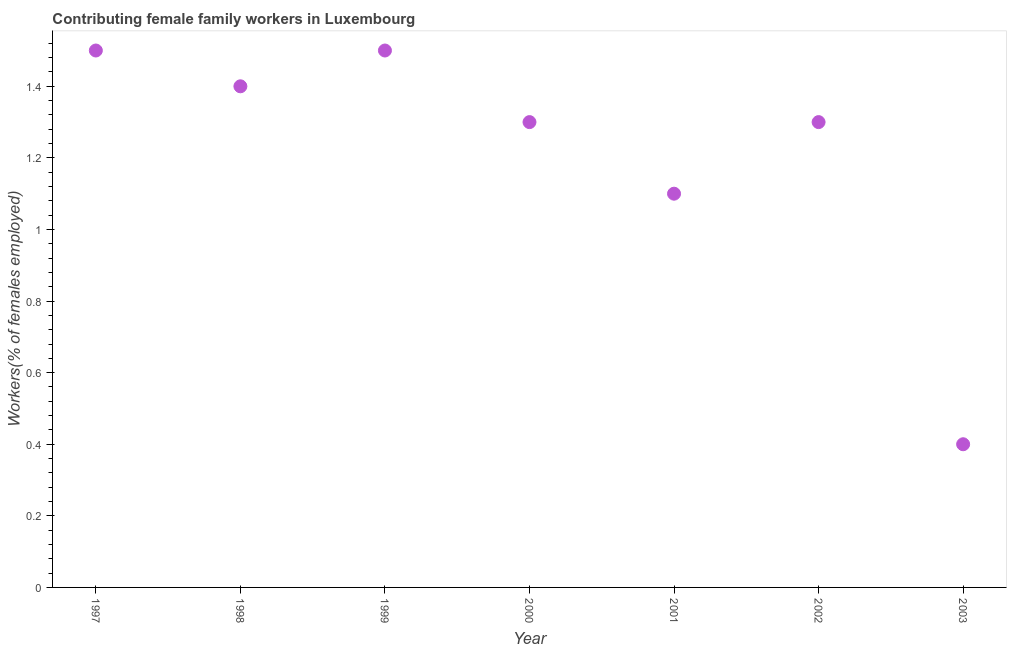What is the contributing female family workers in 2000?
Provide a succinct answer. 1.3. Across all years, what is the minimum contributing female family workers?
Offer a very short reply. 0.4. In which year was the contributing female family workers minimum?
Your response must be concise. 2003. What is the sum of the contributing female family workers?
Provide a succinct answer. 8.5. What is the difference between the contributing female family workers in 1998 and 2000?
Make the answer very short. 0.1. What is the average contributing female family workers per year?
Your response must be concise. 1.21. What is the median contributing female family workers?
Provide a short and direct response. 1.3. In how many years, is the contributing female family workers greater than 1.36 %?
Keep it short and to the point. 3. What is the ratio of the contributing female family workers in 2001 to that in 2002?
Give a very brief answer. 0.85. Is the sum of the contributing female family workers in 1999 and 2003 greater than the maximum contributing female family workers across all years?
Your answer should be compact. Yes. What is the difference between the highest and the lowest contributing female family workers?
Ensure brevity in your answer.  1.1. How many years are there in the graph?
Make the answer very short. 7. Does the graph contain grids?
Ensure brevity in your answer.  No. What is the title of the graph?
Provide a succinct answer. Contributing female family workers in Luxembourg. What is the label or title of the X-axis?
Provide a succinct answer. Year. What is the label or title of the Y-axis?
Give a very brief answer. Workers(% of females employed). What is the Workers(% of females employed) in 1997?
Provide a succinct answer. 1.5. What is the Workers(% of females employed) in 1998?
Your response must be concise. 1.4. What is the Workers(% of females employed) in 1999?
Your answer should be compact. 1.5. What is the Workers(% of females employed) in 2000?
Give a very brief answer. 1.3. What is the Workers(% of females employed) in 2001?
Make the answer very short. 1.1. What is the Workers(% of females employed) in 2002?
Ensure brevity in your answer.  1.3. What is the Workers(% of females employed) in 2003?
Provide a short and direct response. 0.4. What is the difference between the Workers(% of females employed) in 1997 and 1998?
Give a very brief answer. 0.1. What is the difference between the Workers(% of females employed) in 1997 and 2001?
Your response must be concise. 0.4. What is the difference between the Workers(% of females employed) in 1997 and 2002?
Provide a short and direct response. 0.2. What is the difference between the Workers(% of females employed) in 1997 and 2003?
Your response must be concise. 1.1. What is the difference between the Workers(% of females employed) in 1998 and 2000?
Your answer should be compact. 0.1. What is the difference between the Workers(% of females employed) in 1998 and 2001?
Ensure brevity in your answer.  0.3. What is the difference between the Workers(% of females employed) in 1998 and 2002?
Offer a very short reply. 0.1. What is the difference between the Workers(% of females employed) in 1999 and 2000?
Your answer should be very brief. 0.2. What is the difference between the Workers(% of females employed) in 2000 and 2001?
Your answer should be compact. 0.2. What is the difference between the Workers(% of females employed) in 2000 and 2002?
Offer a very short reply. 0. What is the difference between the Workers(% of females employed) in 2000 and 2003?
Keep it short and to the point. 0.9. What is the difference between the Workers(% of females employed) in 2001 and 2003?
Provide a succinct answer. 0.7. What is the ratio of the Workers(% of females employed) in 1997 to that in 1998?
Make the answer very short. 1.07. What is the ratio of the Workers(% of females employed) in 1997 to that in 1999?
Ensure brevity in your answer.  1. What is the ratio of the Workers(% of females employed) in 1997 to that in 2000?
Your answer should be compact. 1.15. What is the ratio of the Workers(% of females employed) in 1997 to that in 2001?
Ensure brevity in your answer.  1.36. What is the ratio of the Workers(% of females employed) in 1997 to that in 2002?
Make the answer very short. 1.15. What is the ratio of the Workers(% of females employed) in 1997 to that in 2003?
Make the answer very short. 3.75. What is the ratio of the Workers(% of females employed) in 1998 to that in 1999?
Offer a terse response. 0.93. What is the ratio of the Workers(% of females employed) in 1998 to that in 2000?
Provide a succinct answer. 1.08. What is the ratio of the Workers(% of females employed) in 1998 to that in 2001?
Provide a succinct answer. 1.27. What is the ratio of the Workers(% of females employed) in 1998 to that in 2002?
Offer a very short reply. 1.08. What is the ratio of the Workers(% of females employed) in 1999 to that in 2000?
Your response must be concise. 1.15. What is the ratio of the Workers(% of females employed) in 1999 to that in 2001?
Give a very brief answer. 1.36. What is the ratio of the Workers(% of females employed) in 1999 to that in 2002?
Give a very brief answer. 1.15. What is the ratio of the Workers(% of females employed) in 1999 to that in 2003?
Keep it short and to the point. 3.75. What is the ratio of the Workers(% of females employed) in 2000 to that in 2001?
Provide a succinct answer. 1.18. What is the ratio of the Workers(% of females employed) in 2000 to that in 2002?
Offer a terse response. 1. What is the ratio of the Workers(% of females employed) in 2000 to that in 2003?
Provide a short and direct response. 3.25. What is the ratio of the Workers(% of females employed) in 2001 to that in 2002?
Your answer should be compact. 0.85. What is the ratio of the Workers(% of females employed) in 2001 to that in 2003?
Keep it short and to the point. 2.75. What is the ratio of the Workers(% of females employed) in 2002 to that in 2003?
Make the answer very short. 3.25. 